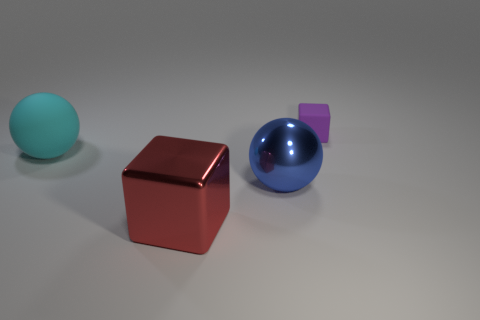What material do the objects look like they're made from? The objects exhibit smooth and reflective surfaces, suggesting they could be made of materials like polished metal or plastic. Such materials are commonly used to create a sleek and modern aesthetic. Is there any indication of the size of these objects, or what their real-world scale might be? Without a reference object of a known size, it's challenging to ascertain their exact scale. However, based on the familiar spherical and cubic shapes, one might infer they are within a size range that could comfortably fit within an average person's hands. 